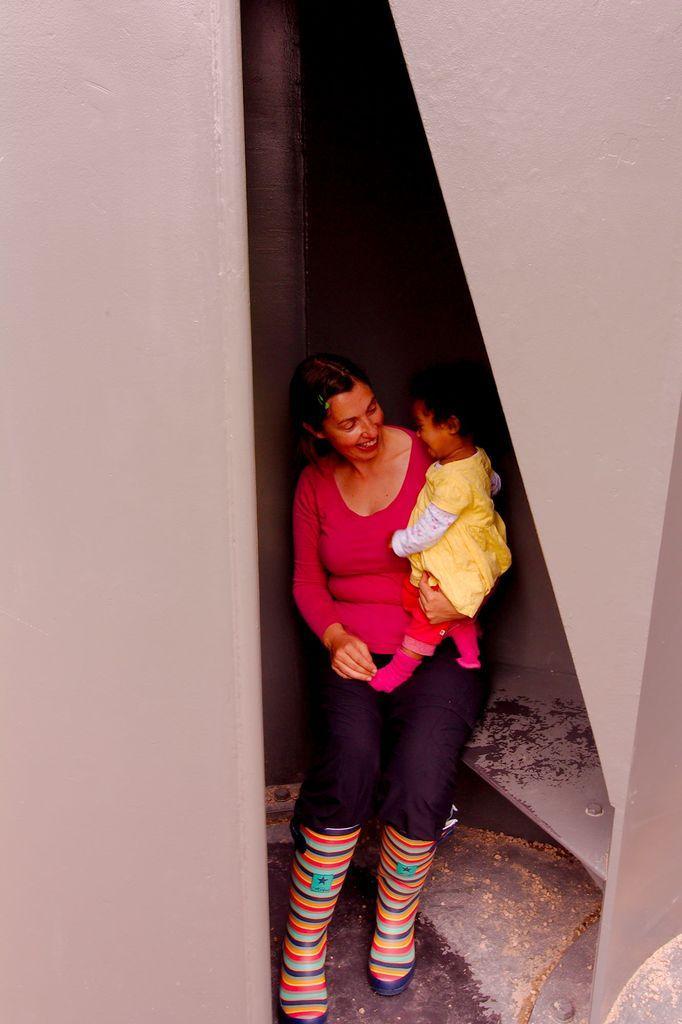Could you give a brief overview of what you see in this image? In this image we can see a lady carrying a baby, also we can see the walls. 